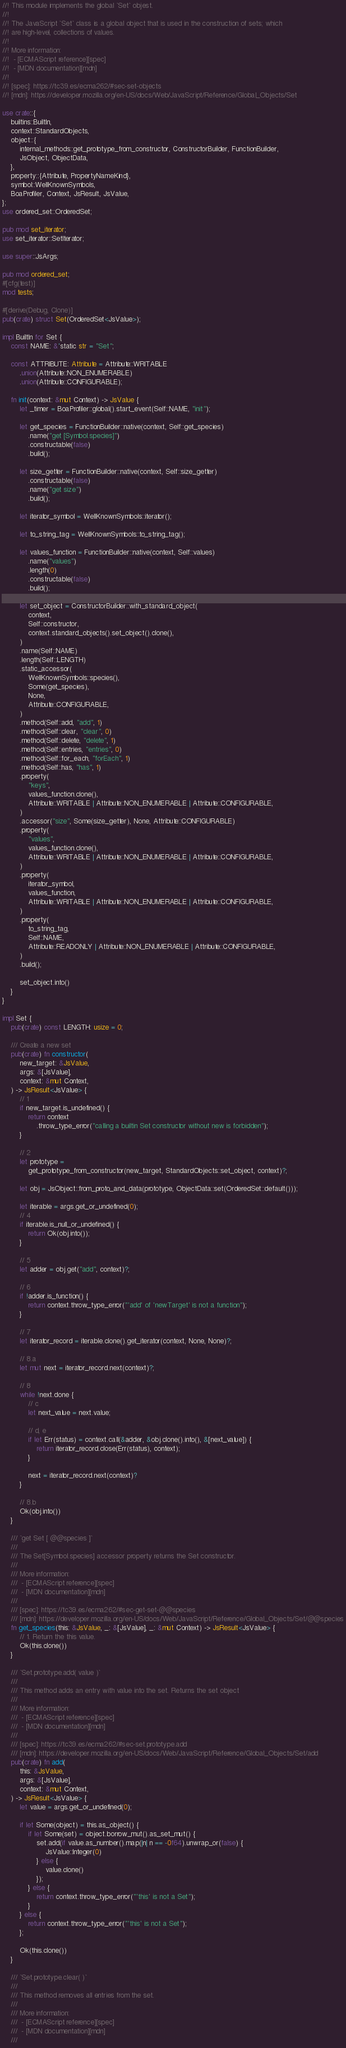Convert code to text. <code><loc_0><loc_0><loc_500><loc_500><_Rust_>//! This module implements the global `Set` objest.
//!
//! The JavaScript `Set` class is a global object that is used in the construction of sets; which
//! are high-level, collections of values.
//!
//! More information:
//!  - [ECMAScript reference][spec]
//!  - [MDN documentation][mdn]
//!
//! [spec]: https://tc39.es/ecma262/#sec-set-objects
//! [mdn]: https://developer.mozilla.org/en-US/docs/Web/JavaScript/Reference/Global_Objects/Set

use crate::{
    builtins::BuiltIn,
    context::StandardObjects,
    object::{
        internal_methods::get_prototype_from_constructor, ConstructorBuilder, FunctionBuilder,
        JsObject, ObjectData,
    },
    property::{Attribute, PropertyNameKind},
    symbol::WellKnownSymbols,
    BoaProfiler, Context, JsResult, JsValue,
};
use ordered_set::OrderedSet;

pub mod set_iterator;
use set_iterator::SetIterator;

use super::JsArgs;

pub mod ordered_set;
#[cfg(test)]
mod tests;

#[derive(Debug, Clone)]
pub(crate) struct Set(OrderedSet<JsValue>);

impl BuiltIn for Set {
    const NAME: &'static str = "Set";

    const ATTRIBUTE: Attribute = Attribute::WRITABLE
        .union(Attribute::NON_ENUMERABLE)
        .union(Attribute::CONFIGURABLE);

    fn init(context: &mut Context) -> JsValue {
        let _timer = BoaProfiler::global().start_event(Self::NAME, "init");

        let get_species = FunctionBuilder::native(context, Self::get_species)
            .name("get [Symbol.species]")
            .constructable(false)
            .build();

        let size_getter = FunctionBuilder::native(context, Self::size_getter)
            .constructable(false)
            .name("get size")
            .build();

        let iterator_symbol = WellKnownSymbols::iterator();

        let to_string_tag = WellKnownSymbols::to_string_tag();

        let values_function = FunctionBuilder::native(context, Self::values)
            .name("values")
            .length(0)
            .constructable(false)
            .build();

        let set_object = ConstructorBuilder::with_standard_object(
            context,
            Self::constructor,
            context.standard_objects().set_object().clone(),
        )
        .name(Self::NAME)
        .length(Self::LENGTH)
        .static_accessor(
            WellKnownSymbols::species(),
            Some(get_species),
            None,
            Attribute::CONFIGURABLE,
        )
        .method(Self::add, "add", 1)
        .method(Self::clear, "clear", 0)
        .method(Self::delete, "delete", 1)
        .method(Self::entries, "entries", 0)
        .method(Self::for_each, "forEach", 1)
        .method(Self::has, "has", 1)
        .property(
            "keys",
            values_function.clone(),
            Attribute::WRITABLE | Attribute::NON_ENUMERABLE | Attribute::CONFIGURABLE,
        )
        .accessor("size", Some(size_getter), None, Attribute::CONFIGURABLE)
        .property(
            "values",
            values_function.clone(),
            Attribute::WRITABLE | Attribute::NON_ENUMERABLE | Attribute::CONFIGURABLE,
        )
        .property(
            iterator_symbol,
            values_function,
            Attribute::WRITABLE | Attribute::NON_ENUMERABLE | Attribute::CONFIGURABLE,
        )
        .property(
            to_string_tag,
            Self::NAME,
            Attribute::READONLY | Attribute::NON_ENUMERABLE | Attribute::CONFIGURABLE,
        )
        .build();

        set_object.into()
    }
}

impl Set {
    pub(crate) const LENGTH: usize = 0;

    /// Create a new set
    pub(crate) fn constructor(
        new_target: &JsValue,
        args: &[JsValue],
        context: &mut Context,
    ) -> JsResult<JsValue> {
        // 1
        if new_target.is_undefined() {
            return context
                .throw_type_error("calling a builtin Set constructor without new is forbidden");
        }

        // 2
        let prototype =
            get_prototype_from_constructor(new_target, StandardObjects::set_object, context)?;

        let obj = JsObject::from_proto_and_data(prototype, ObjectData::set(OrderedSet::default()));

        let iterable = args.get_or_undefined(0);
        // 4
        if iterable.is_null_or_undefined() {
            return Ok(obj.into());
        }

        // 5
        let adder = obj.get("add", context)?;

        // 6
        if !adder.is_function() {
            return context.throw_type_error("'add' of 'newTarget' is not a function");
        }

        // 7
        let iterator_record = iterable.clone().get_iterator(context, None, None)?;

        // 8.a
        let mut next = iterator_record.next(context)?;

        // 8
        while !next.done {
            // c
            let next_value = next.value;

            // d, e
            if let Err(status) = context.call(&adder, &obj.clone().into(), &[next_value]) {
                return iterator_record.close(Err(status), context);
            }

            next = iterator_record.next(context)?
        }

        // 8.b
        Ok(obj.into())
    }

    /// `get Set [ @@species ]`
    ///
    /// The Set[Symbol.species] accessor property returns the Set constructor.
    ///
    /// More information:
    ///  - [ECMAScript reference][spec]
    ///  - [MDN documentation][mdn]
    ///
    /// [spec]: https://tc39.es/ecma262/#sec-get-set-@@species
    /// [mdn]: https://developer.mozilla.org/en-US/docs/Web/JavaScript/Reference/Global_Objects/Set/@@species
    fn get_species(this: &JsValue, _: &[JsValue], _: &mut Context) -> JsResult<JsValue> {
        // 1. Return the this value.
        Ok(this.clone())
    }

    /// `Set.prototype.add( value )`
    ///
    /// This method adds an entry with value into the set. Returns the set object
    ///
    /// More information:
    ///  - [ECMAScript reference][spec]
    ///  - [MDN documentation][mdn]
    ///
    /// [spec]: https://tc39.es/ecma262/#sec-set.prototype.add
    /// [mdn]: https://developer.mozilla.org/en-US/docs/Web/JavaScript/Reference/Global_Objects/Set/add
    pub(crate) fn add(
        this: &JsValue,
        args: &[JsValue],
        context: &mut Context,
    ) -> JsResult<JsValue> {
        let value = args.get_or_undefined(0);

        if let Some(object) = this.as_object() {
            if let Some(set) = object.borrow_mut().as_set_mut() {
                set.add(if value.as_number().map(|n| n == -0f64).unwrap_or(false) {
                    JsValue::Integer(0)
                } else {
                    value.clone()
                });
            } else {
                return context.throw_type_error("'this' is not a Set");
            }
        } else {
            return context.throw_type_error("'this' is not a Set");
        };

        Ok(this.clone())
    }

    /// `Set.prototype.clear( )`
    ///
    /// This method removes all entries from the set.
    ///
    /// More information:
    ///  - [ECMAScript reference][spec]
    ///  - [MDN documentation][mdn]
    ///</code> 